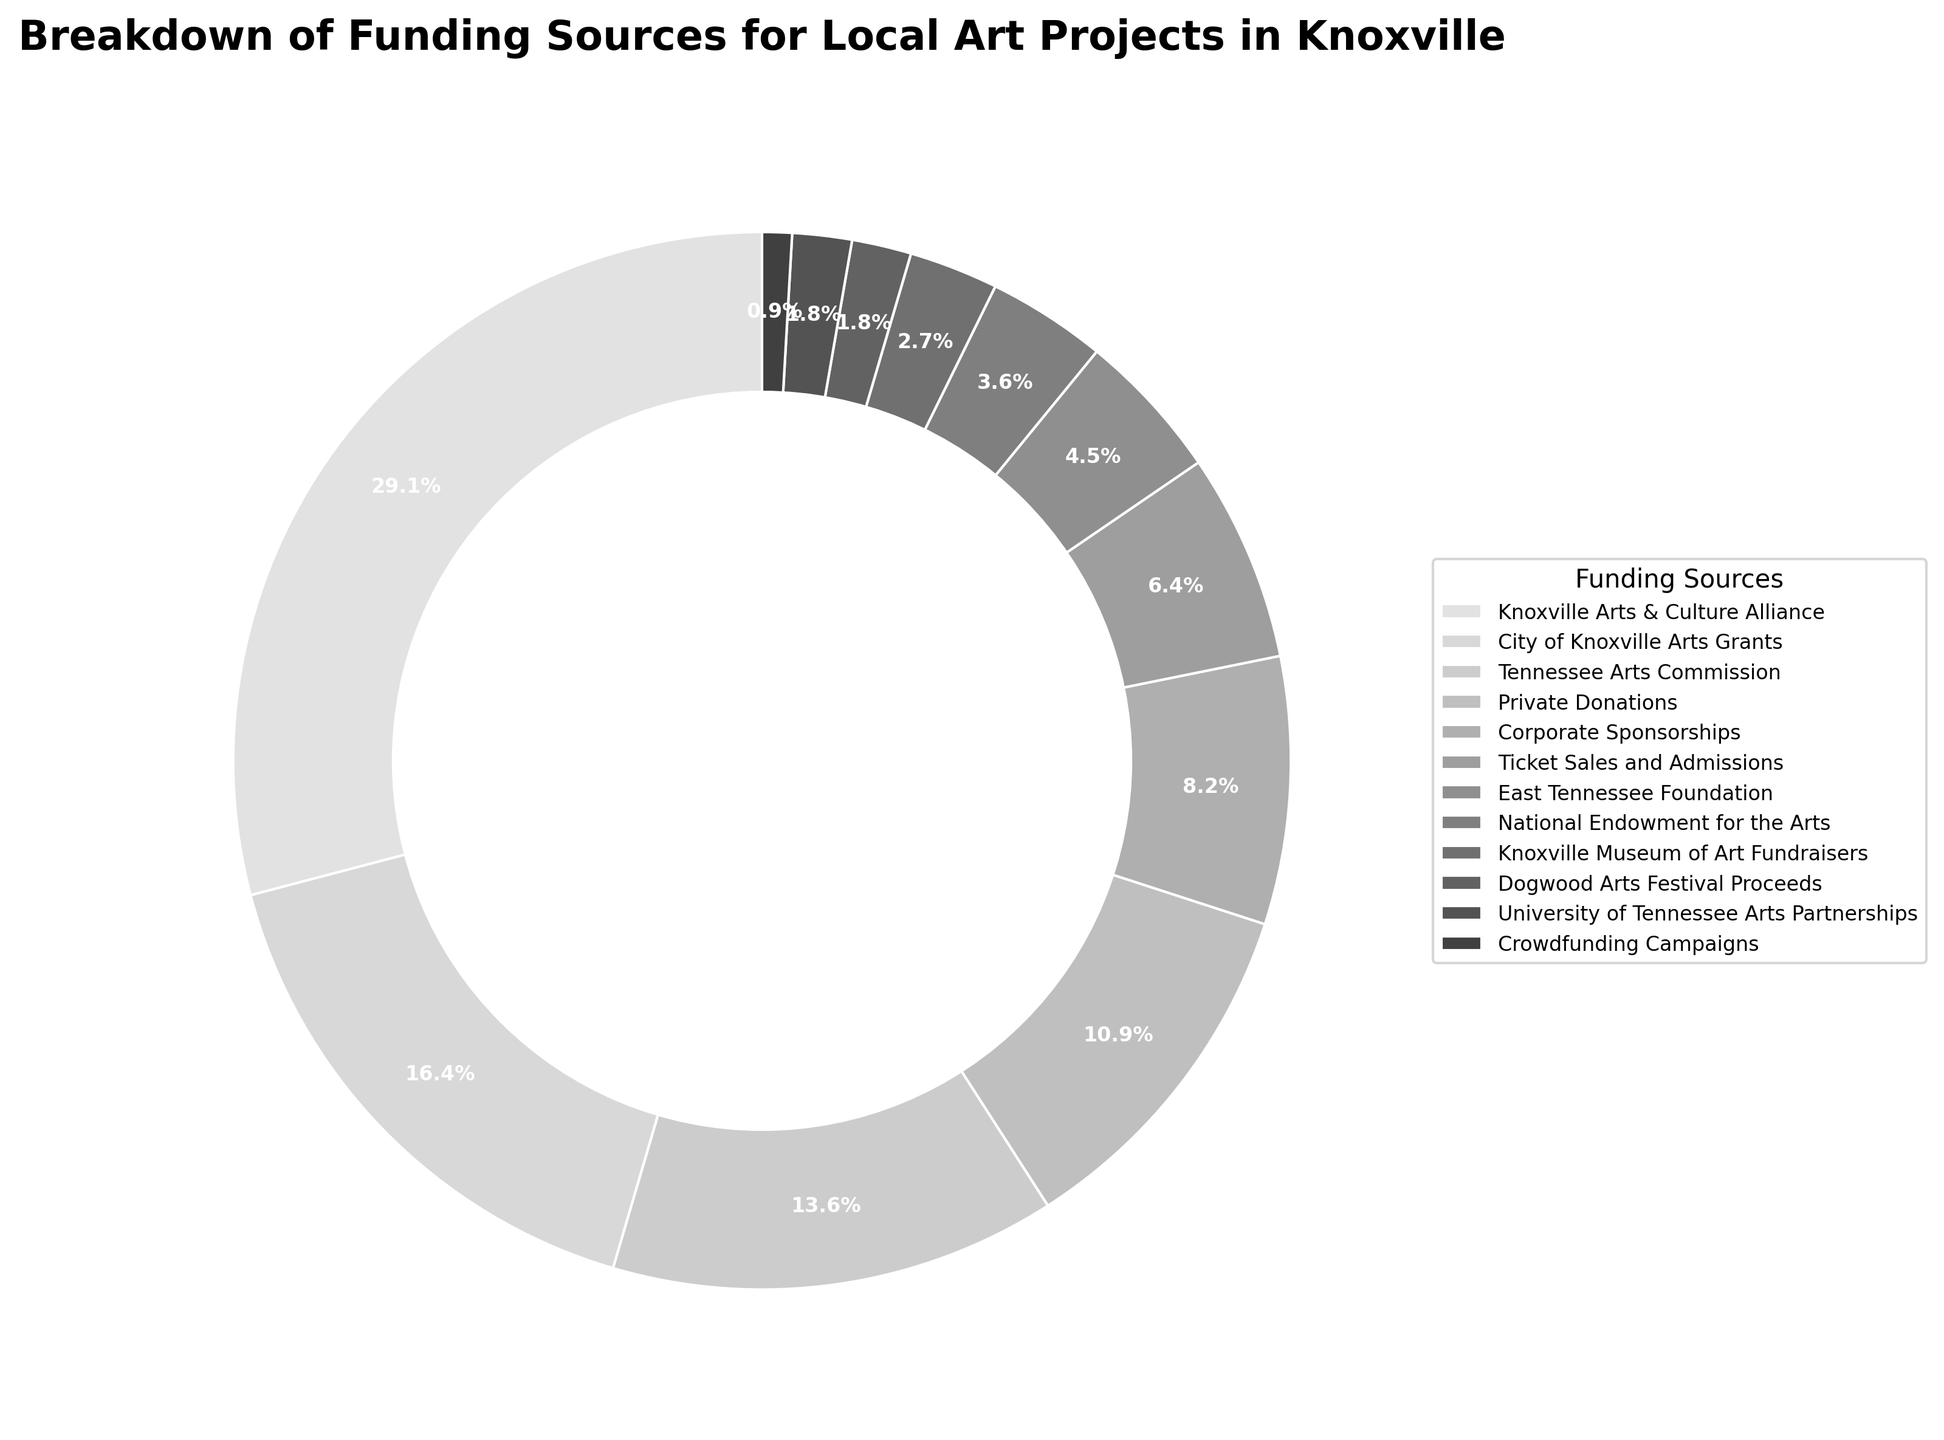What's the largest funding source for local art projects in Knoxville? The largest funding source can be identified by the section of the pie chart with the largest slice. In this case, it is the Knoxville Arts & Culture Alliance with 32%.
Answer: Knoxville Arts & Culture Alliance Which funding source contributes the least to local art projects in Knoxville? The smallest slice in the pie chart represents the funding source that contributes the least. It is the Crowdfunding Campaigns with 1%.
Answer: Crowdfunding Campaigns How much more does the City of Knoxville Arts Grants contribute than the National Endowment for the Arts? The City of Knoxville Arts Grants contributes 18%, and the National Endowment for the Arts contributes 4%. Subtracting these two gives the difference: 18% - 4% = 14%.
Answer: 14% What is the combined contribution of Private Donations and Corporate Sponsorships? Add the percentages of Private Donations and Corporate Sponsorships: 12% + 9% = 21%.
Answer: 21% Which funding sources collectively make up more than 50% of the total funding? To determine which sources collectively make up more than 50%, we start summing from the largest to smallest contribution until the total exceeds 50%. Knoxville Arts & Culture Alliance (32%) + City of Knoxville Arts Grants (18%) = 50%. Thus, these two sources collectively make up exactly 50%.
Answer: Knoxville Arts & Culture Alliance and City of Knoxville Arts Grants Is the contribution of Ticket Sales and Admissions greater than that of the East Tennessee Foundation? Ticket Sales and Admissions contribute 7%, while the East Tennessee Foundation contributes 5%. Since 7% > 5%, Ticket Sales and Admissions contribute more.
Answer: Yes What is the average percentage contribution of the Tennessee Arts Commission, Corporate Sponsorships, and the East Tennessee Foundation? Adding their percentages: Tennessee Arts Commission (15%), Corporate Sponsorships (9%), and East Tennessee Foundation (5%), we get: 15% + 9% + 5% = 29%. Dividing by the number of funding sources (3), we get: 29% / 3 = 9.67%.
Answer: 9.67% How does the contribution of the Knoxville Museum of Art Fundraisers compare to the Dogwood Arts Festival Proceeds? The Knoxville Museum of Art Fundraisers contribute 3%, while the Dogwood Arts Festival Proceeds contribute 2%. Since 3% > 2%, the Knoxville Museum of Art Fundraisers contribute more.
Answer: Knoxville Museum of Art Fundraisers contribute more What is the total contribution of sources that contribute less than 10% each? The sources contributing less than 10% are Corporate Sponsorships (9%), Ticket Sales and Admissions (7%), East Tennessee Foundation (5%), National Endowment for the Arts (4%), Knoxville Museum of Art Fundraisers (3%), Dogwood Arts Festival Proceeds (2%), University of Tennessee Arts Partnerships (2%), and Crowdfunding Campaigns (1%). Summing these: 9% + 7% + 5% + 4% + 3% + 2% + 2% + 1% = 33%.
Answer: 33% 